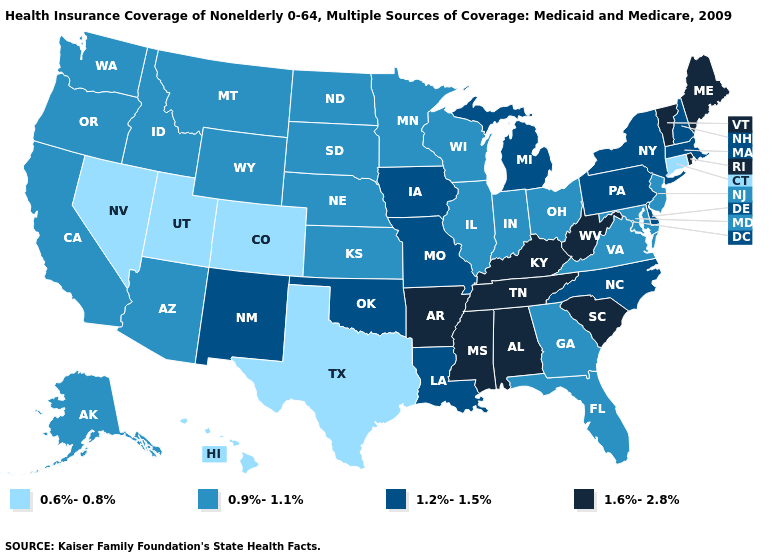What is the lowest value in states that border Virginia?
Short answer required. 0.9%-1.1%. What is the highest value in the South ?
Write a very short answer. 1.6%-2.8%. Which states have the highest value in the USA?
Answer briefly. Alabama, Arkansas, Kentucky, Maine, Mississippi, Rhode Island, South Carolina, Tennessee, Vermont, West Virginia. What is the highest value in states that border Kansas?
Give a very brief answer. 1.2%-1.5%. What is the highest value in states that border Nevada?
Keep it brief. 0.9%-1.1%. Which states have the lowest value in the Northeast?
Quick response, please. Connecticut. Does Idaho have the lowest value in the West?
Be succinct. No. What is the value of Rhode Island?
Write a very short answer. 1.6%-2.8%. What is the value of New York?
Keep it brief. 1.2%-1.5%. What is the value of Louisiana?
Answer briefly. 1.2%-1.5%. Which states hav the highest value in the South?
Be succinct. Alabama, Arkansas, Kentucky, Mississippi, South Carolina, Tennessee, West Virginia. Which states have the highest value in the USA?
Give a very brief answer. Alabama, Arkansas, Kentucky, Maine, Mississippi, Rhode Island, South Carolina, Tennessee, Vermont, West Virginia. What is the lowest value in states that border Texas?
Keep it brief. 1.2%-1.5%. What is the value of Alaska?
Concise answer only. 0.9%-1.1%. 